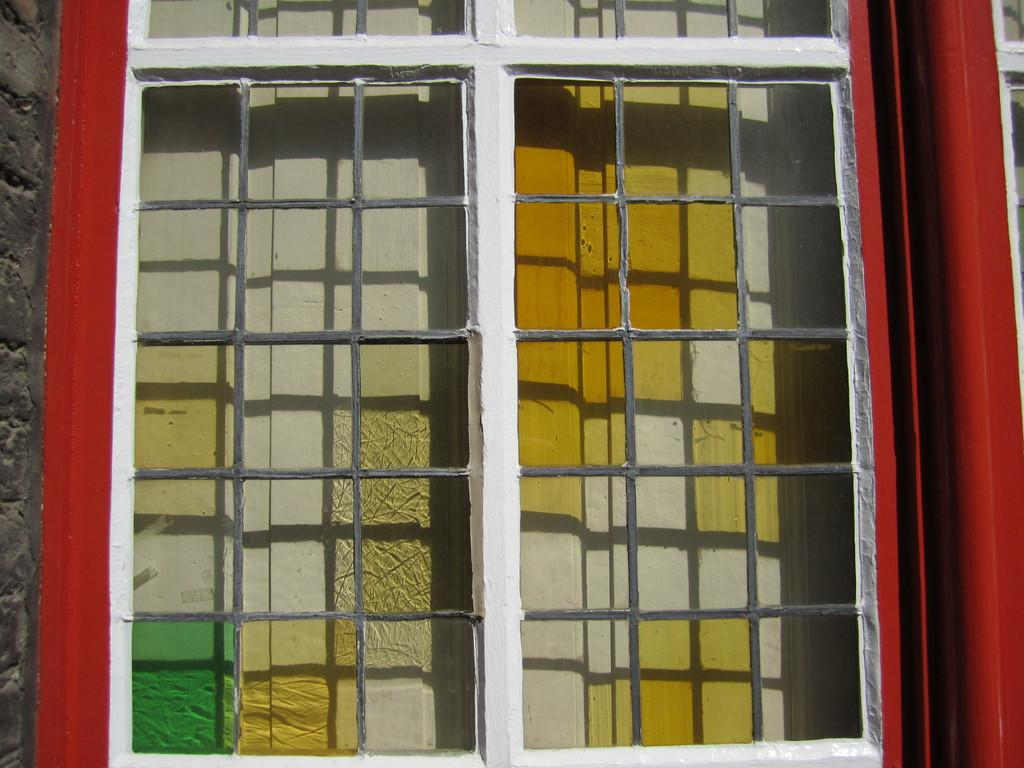What type of opening can be seen in the building in the image? There is a window on a building in the image. Is there any access point associated with the window? Yes, there is a door associated with the window in the image. What type of window treatment is visible in the image? There is a curtain visible in the image. What type of cemetery can be seen through the window in the image? There is no cemetery visible through the window in the image; it only shows a window, door, and curtain. How many bulbs are present in the image? There is no mention of bulbs in the image, so it cannot be determined how many are present. 